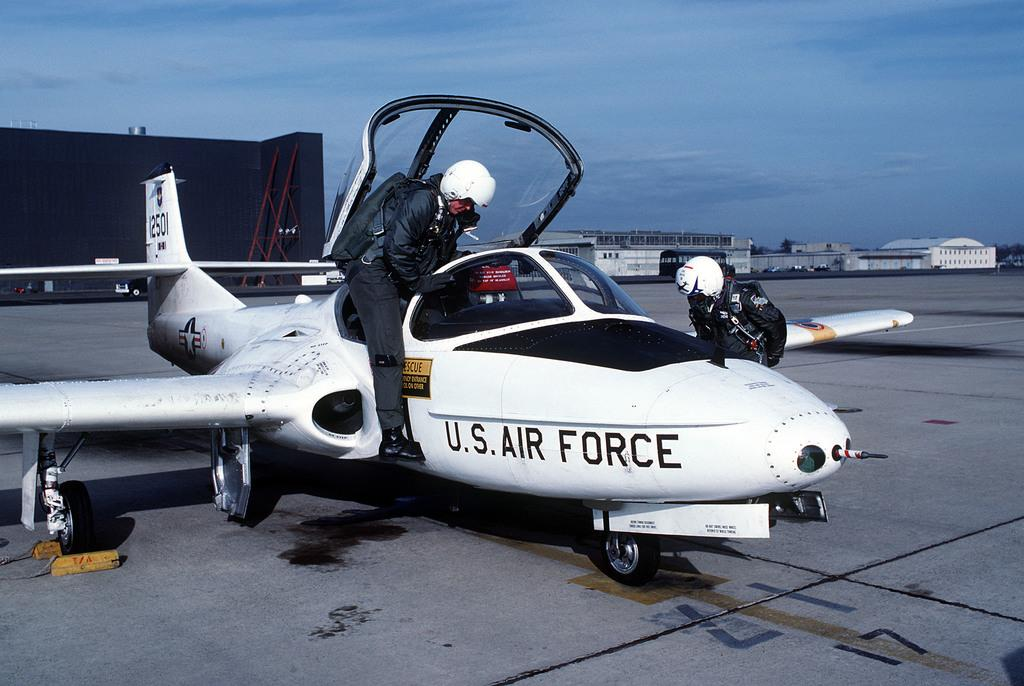Provide a one-sentence caption for the provided image. A US Air Force Pilot entering the cockpit. 